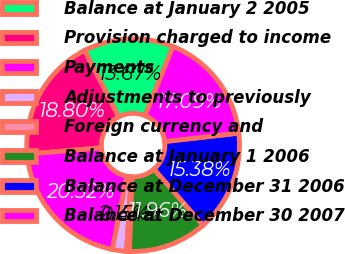<chart> <loc_0><loc_0><loc_500><loc_500><pie_chart><fcel>Balance at January 2 2005<fcel>Provision charged to income<fcel>Payments<fcel>Adjustments to previously<fcel>Foreign currency and<fcel>Balance at January 1 2006<fcel>Balance at December 31 2006<fcel>Balance at December 30 2007<nl><fcel>13.67%<fcel>18.8%<fcel>20.52%<fcel>2.15%<fcel>0.44%<fcel>11.96%<fcel>15.38%<fcel>17.09%<nl></chart> 